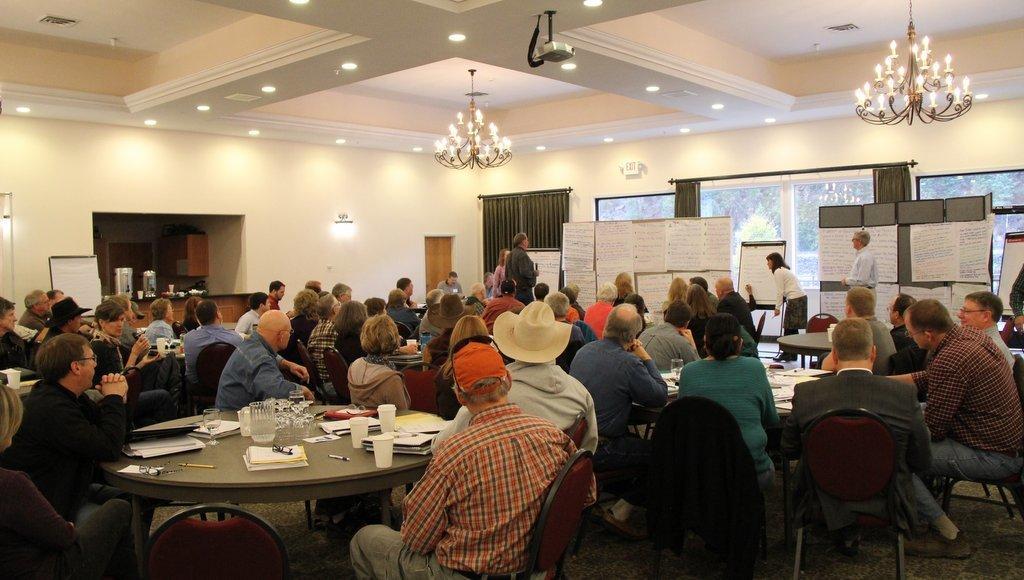How would you summarize this image in a sentence or two? In this image there are group of people sitting around the table. There are cups, papers, pens on the table. there are lights at the top, at the back there are curtains and trees outside of the window. 